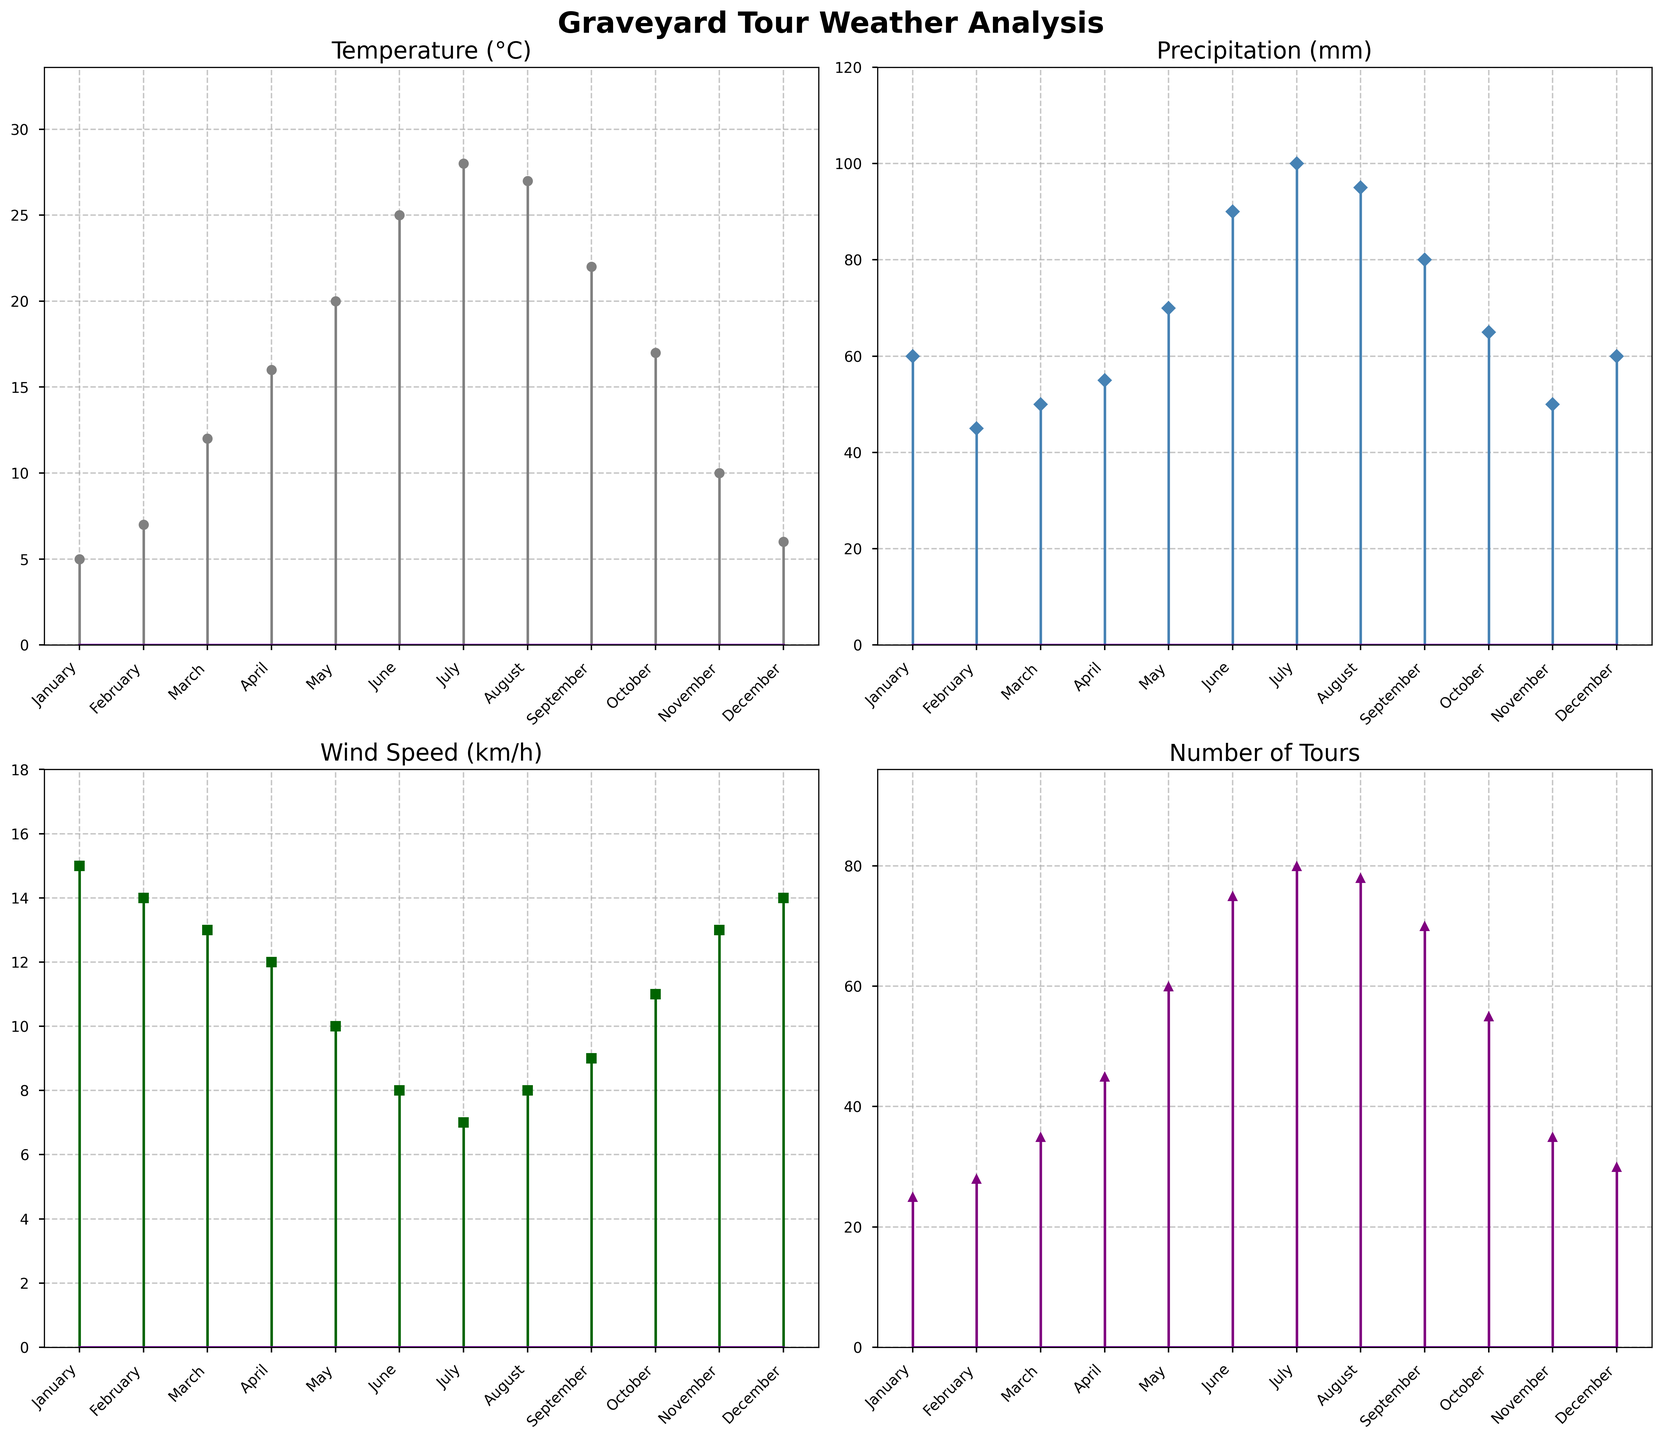What is the highest temperature recorded? Look at the stem plot titled 'Temperature (°C)', the highest point on the y-axis indicates the maximum temperature value.
Answer: 28°C What month has the most precipitation and how much is it? Referencing the plot titled 'Precipitation (mm)', observe the tallest stem to find the month with the highest precipitation and read the corresponding value.
Answer: July, 100 mm How does the number of tours in June compare to the number of tours in December? Compare the height of stems in June and December in the 'Number of Tours' plot to find the respective values and then compare them.
Answer: June has more tours, 75 compared to December with 30 Which month has the lowest wind speed, and how low is it? In the 'Wind Speed (km/h)' plot, find the shortest stem and read off the month and value from the x-axis and y-axis, respectively.
Answer: July, 7 km/h What is the difference in the number of tours between August and February? Check the 'Number of Tours' plot for the respective values in August (78) and February (28) and subtract the lower from the higher.
Answer: 50 tours What is the average temperature over the months? Sum the temperature values (5+7+12+16+20+25+28+27+22+17+10+6) and divide by the number of months (12).
Answer: 16.5°C Are there any months with more than double the amount of wind speed of another month? Compare values in the 'Wind Speed (km/h)' plot, looking for instances where one month has more than twice the wind speed of another.
Answer: No, the maximum wind speed (15 km/h in January) is not more than double the minimum (7 km/h in July) What months have the same amount of precipitation? Look at the 'Precipitation (mm)' plot to identify months with identical stem heights.
Answer: January and December, both with 60 mm Which month has the lowest number of tours and what is the value? Check the 'Number of Tours' plot for the shortest stem, which represents the month with the fewest tours, and note its value.
Answer: January, 25 tours In which months does the temperature exceed 20°C and how many tours were conducted in those months? Identify months in the 'Temperature (°C)' plot where the value is above 20°C, then refer to the 'Number of Tours' plot for the corresponding number of tours in those months (June, July, August, September).
Answer: June: 75, July: 80, August: 78, September: 70 